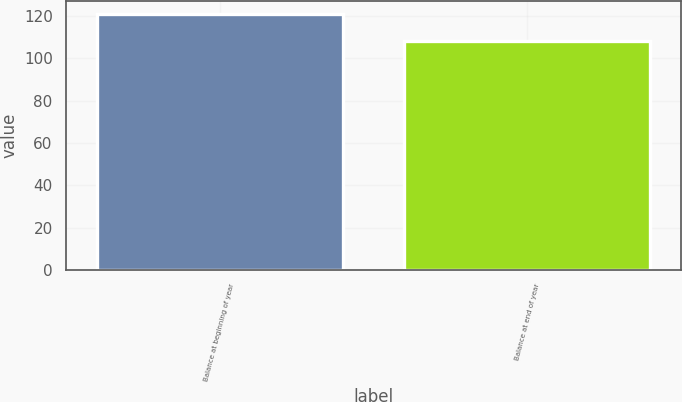<chart> <loc_0><loc_0><loc_500><loc_500><bar_chart><fcel>Balance at beginning of year<fcel>Balance at end of year<nl><fcel>121<fcel>108<nl></chart> 